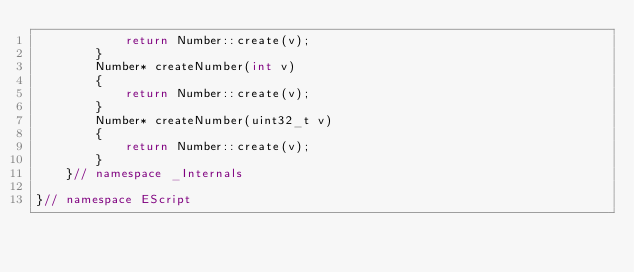Convert code to text. <code><loc_0><loc_0><loc_500><loc_500><_C++_>            return Number::create(v);
        }
        Number* createNumber(int v)
        {
            return Number::create(v);
        }
        Number* createNumber(uint32_t v)
        {
            return Number::create(v);
        }
    }// namespace _Internals

}// namespace EScript
</code> 